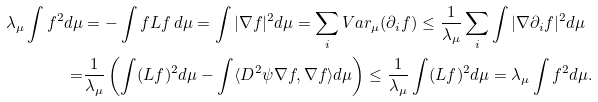Convert formula to latex. <formula><loc_0><loc_0><loc_500><loc_500>\lambda _ { \mu } \int f ^ { 2 } d \mu & = - \int f L f \, d \mu = \int | \nabla f | ^ { 2 } d \mu = \sum _ { i } V a r _ { \mu } ( \partial _ { i } f ) \leq \frac { 1 } { \lambda _ { \mu } } \sum _ { i } \int | \nabla \partial _ { i } f | ^ { 2 } d \mu \\ = & \frac { 1 } { \lambda _ { \mu } } \left ( \int ( L f ) ^ { 2 } d \mu - \int \langle D ^ { 2 } \psi \nabla f , \nabla f \rangle d \mu \right ) \leq \frac { 1 } { \lambda _ { \mu } } \int ( L f ) ^ { 2 } d \mu = \lambda _ { \mu } \int f ^ { 2 } d \mu .</formula> 